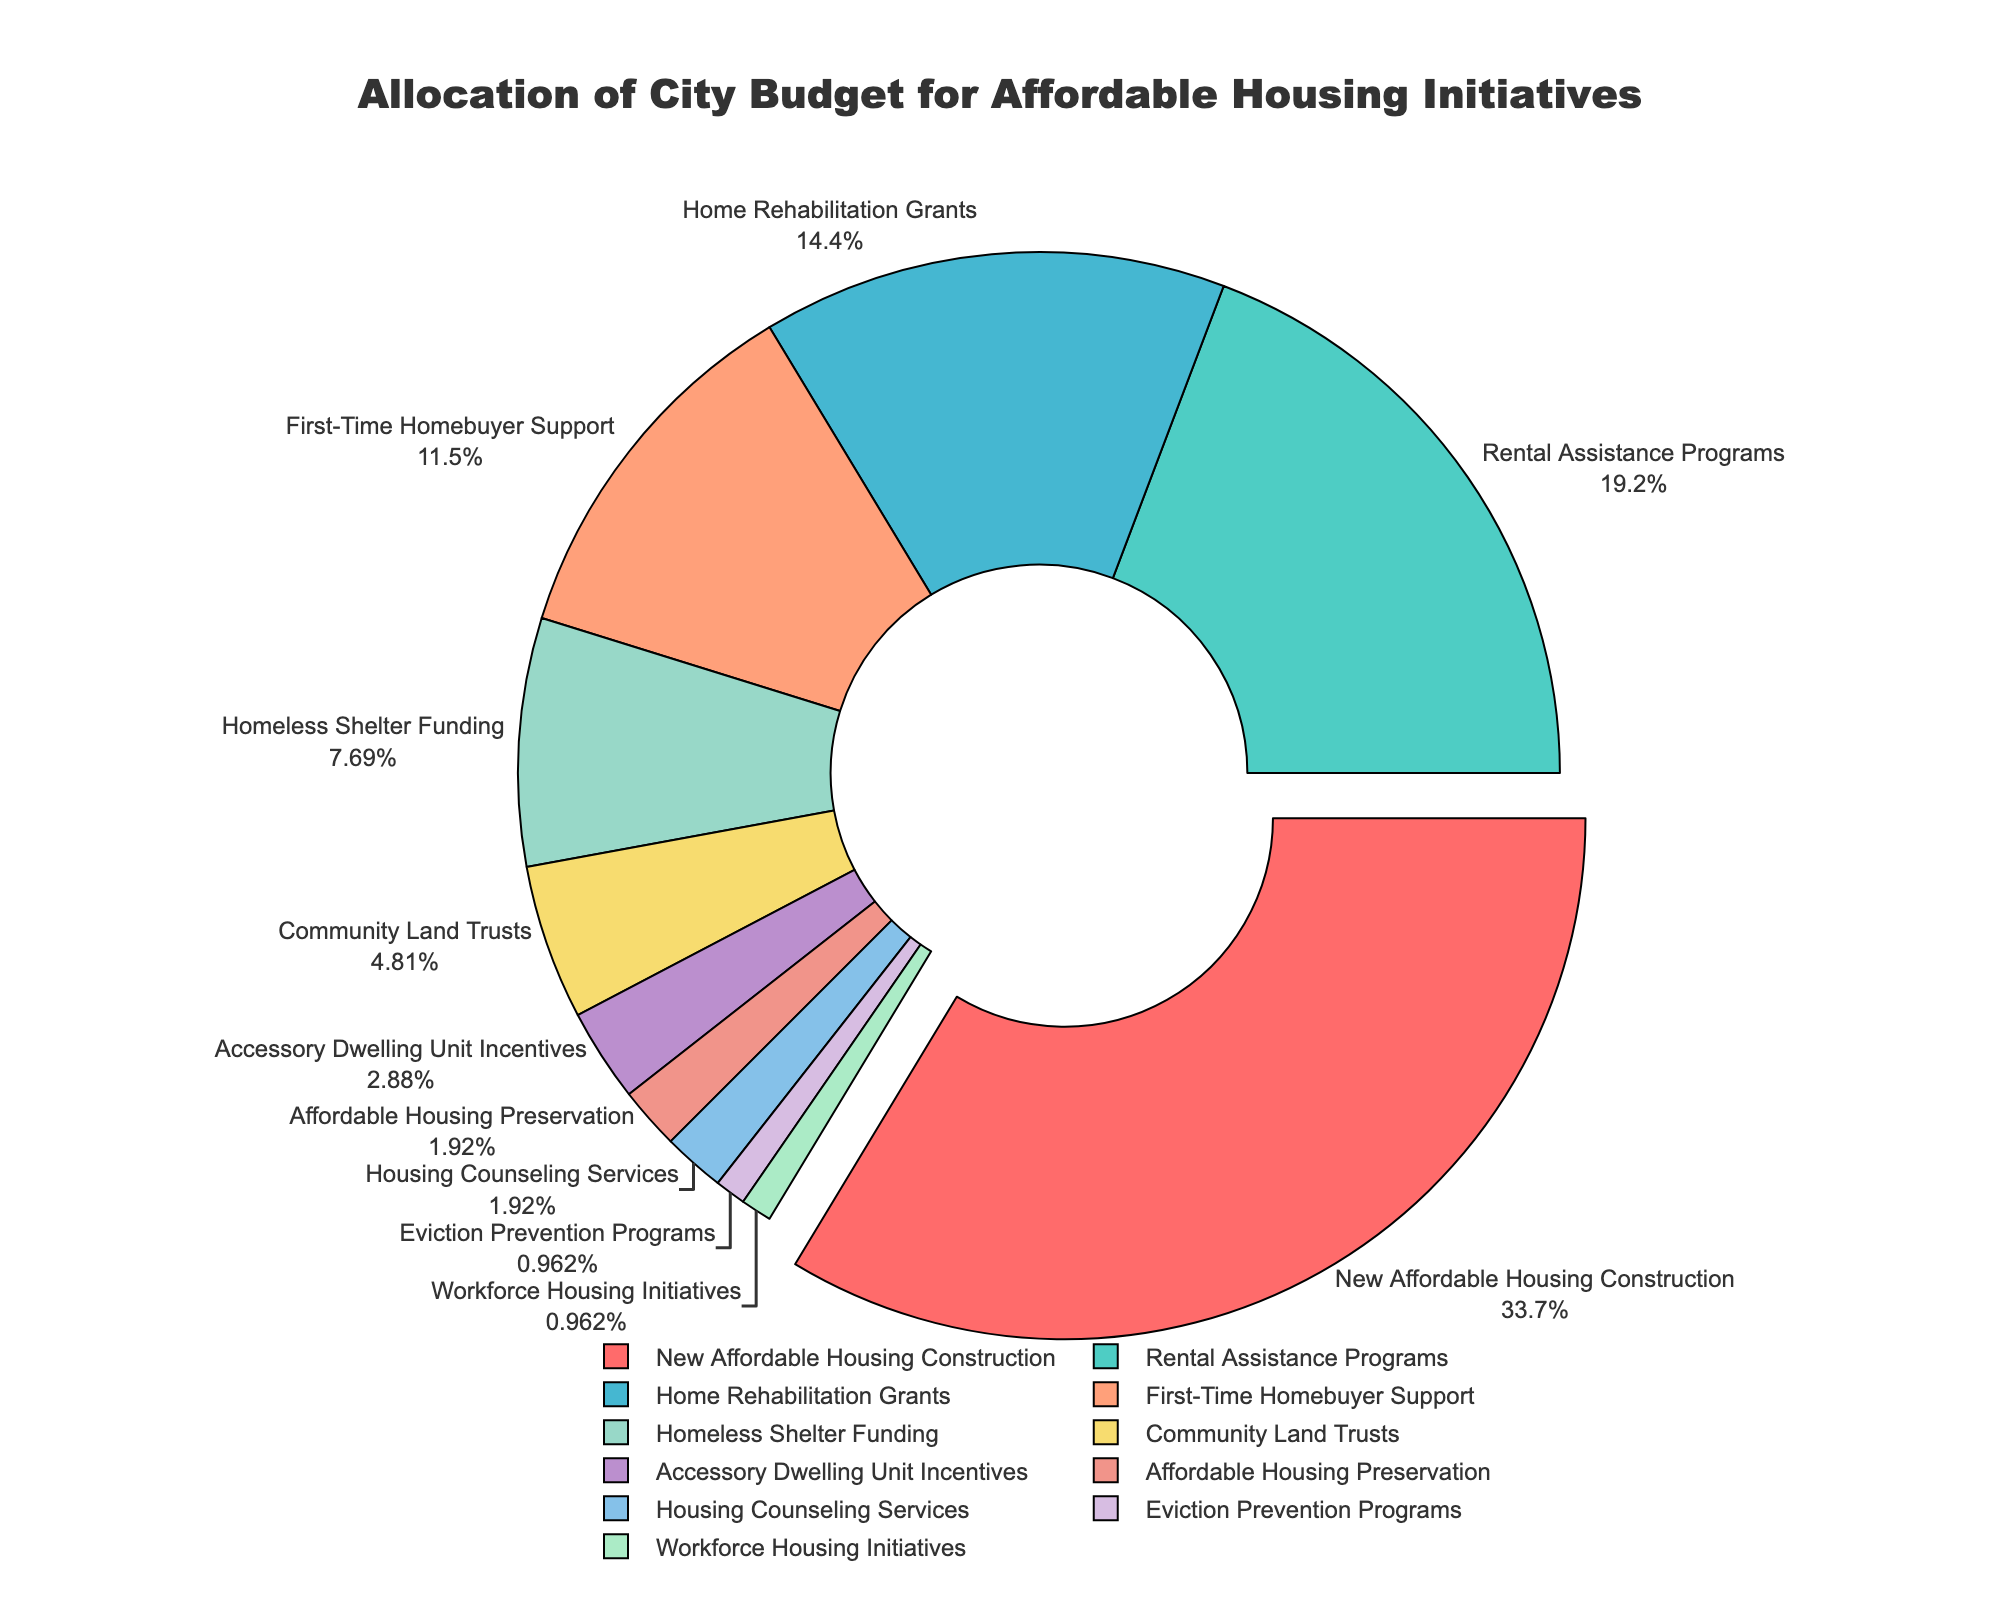What is the largest category in the budget allocation? When we look at the pie chart, the category with the slice pulled out is the largest. This is 'New Affordable Housing Construction' with 35%.
Answer: New Affordable Housing Construction Which category received more funding: Rental Assistance Programs or Home Rehabilitation Grants? To compare the funding, look at the percentages. Rental Assistance Programs received 20%, while Home Rehabilitation Grants got 15%. 20% is greater than 15%.
Answer: Rental Assistance Programs What is the total percentage allocated to Affordable Housing Preservation, Housing Counseling Services, and Eviction Prevention Programs combined? Add the percentages of the three categories: 2% (Affordable Housing Preservation) + 2% (Housing Counseling Services) + 1% (Eviction Prevention Programs). This results in 5%.
Answer: 5% Which category has the smallest allocation, and what is its percentage? By examining the smallest slice in the pie chart, we see that 'Workforce Housing Initiatives' has the smallest percentage, which is 1%.
Answer: Workforce Housing Initiatives How does the funding for First-Time Homebuyer Support compare to Community Land Trusts? First-Time Homebuyer Support has a 12% allocation, while Community Land Trusts have 5%. 12% is more than 5%.
Answer: First-Time Homebuyer Support What is the total budget percentage allocated to categories with less than 5% each? Categories with less than 5% are Community Land Trusts (5%), Accessory Dwelling Unit Incentives (3%), Affordable Housing Preservation (2%), Housing Counseling Services (2%), Eviction Prevention Programs (1%), and Workforce Housing Initiatives (1%). Sum these percentages: 5% + 3% + 2% + 2% + 1% + 1% = 14%.
Answer: 14% Which categories have equal budget allocations? Looking at the pie chart, Affordable Housing Preservation and Housing Counseling Services both have 2%.
Answer: Affordable Housing Preservation and Housing Counseling Services How much more percentage is allocated to New Affordable Housing Construction than to Homeless Shelter Funding? New Affordable Housing Construction has 35%, and Homeless Shelter Funding has 8%. The difference is 35% - 8% = 27%.
Answer: 27% What is the combined percentage of the top two funded categories? The top two funded categories are 'New Affordable Housing Construction' (35%) and 'Rental Assistance Programs' (20%). The combined percentage is 35% + 20% = 55%.
Answer: 55% What percentage of the budget is used for Housing Counseling Services and Workforce Housing Initiatives together? The percentages for Housing Counseling Services (2%) and Workforce Housing Initiatives (1%) need to be summed: 2% + 1% = 3%.
Answer: 3% 